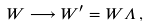Convert formula to latex. <formula><loc_0><loc_0><loc_500><loc_500>W \longrightarrow W ^ { \prime } = W \Lambda \, ,</formula> 